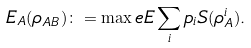Convert formula to latex. <formula><loc_0><loc_0><loc_500><loc_500>E _ { A } ( \rho _ { A B } ) \colon = \max _ { \ } e E \sum _ { i } p _ { i } S ( \rho ^ { i } _ { A } ) .</formula> 